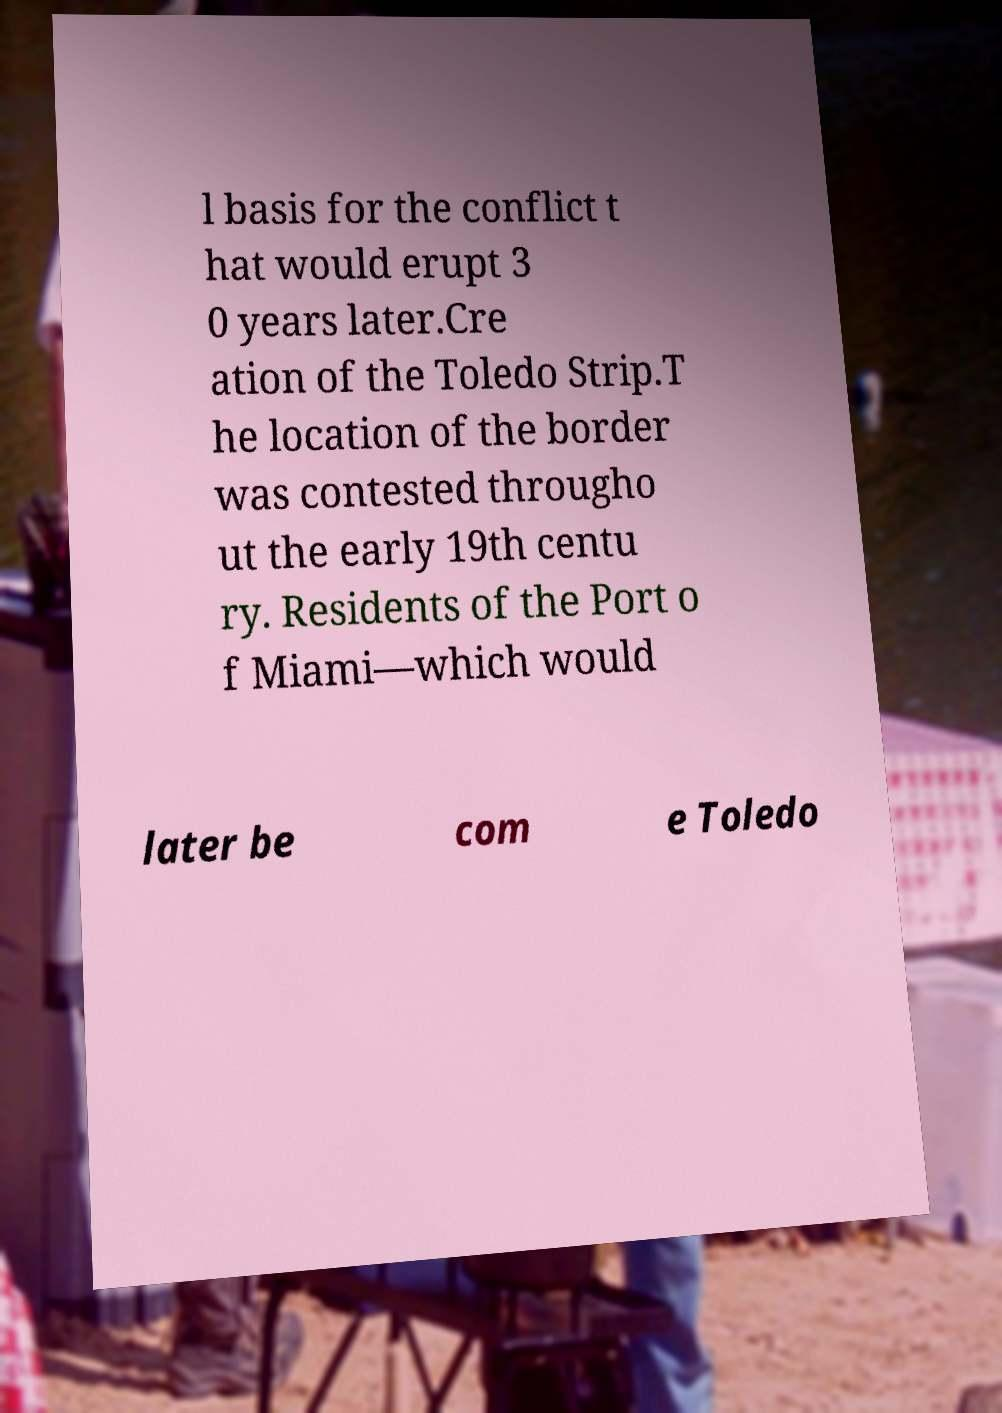Can you accurately transcribe the text from the provided image for me? l basis for the conflict t hat would erupt 3 0 years later.Cre ation of the Toledo Strip.T he location of the border was contested througho ut the early 19th centu ry. Residents of the Port o f Miami—which would later be com e Toledo 